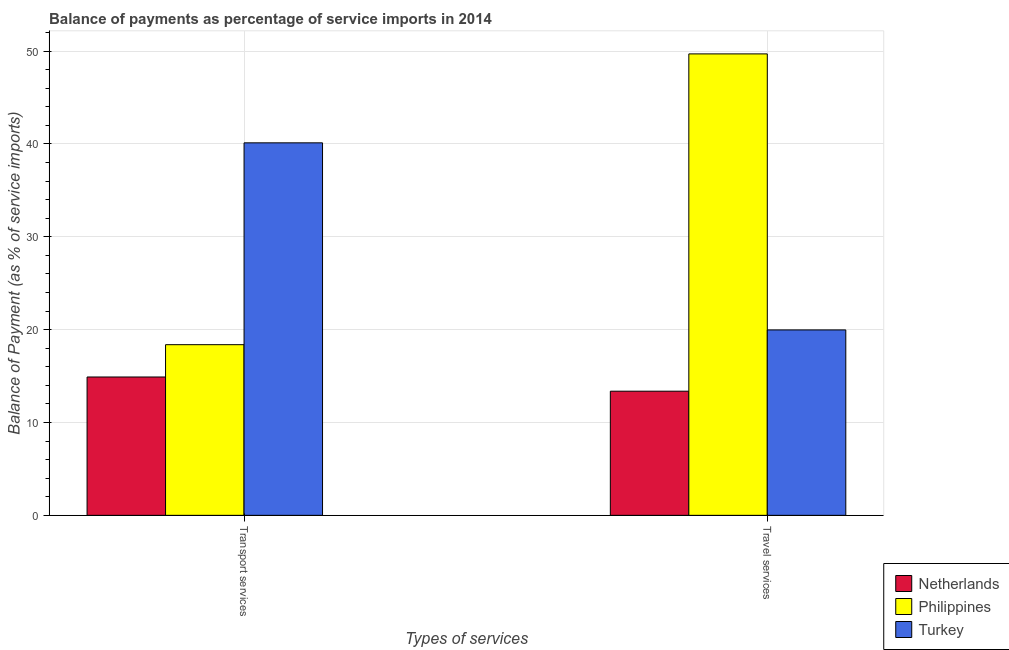How many different coloured bars are there?
Your answer should be very brief. 3. Are the number of bars per tick equal to the number of legend labels?
Offer a terse response. Yes. How many bars are there on the 2nd tick from the left?
Provide a short and direct response. 3. What is the label of the 1st group of bars from the left?
Keep it short and to the point. Transport services. What is the balance of payments of travel services in Turkey?
Your answer should be compact. 19.97. Across all countries, what is the maximum balance of payments of transport services?
Offer a very short reply. 40.12. Across all countries, what is the minimum balance of payments of travel services?
Ensure brevity in your answer.  13.37. In which country was the balance of payments of travel services maximum?
Your response must be concise. Philippines. In which country was the balance of payments of travel services minimum?
Give a very brief answer. Netherlands. What is the total balance of payments of travel services in the graph?
Your response must be concise. 83.03. What is the difference between the balance of payments of transport services in Turkey and that in Philippines?
Offer a terse response. 21.74. What is the difference between the balance of payments of transport services in Turkey and the balance of payments of travel services in Netherlands?
Keep it short and to the point. 26.75. What is the average balance of payments of travel services per country?
Make the answer very short. 27.68. What is the difference between the balance of payments of transport services and balance of payments of travel services in Turkey?
Offer a terse response. 20.15. What is the ratio of the balance of payments of transport services in Netherlands to that in Turkey?
Keep it short and to the point. 0.37. Is the balance of payments of transport services in Philippines less than that in Turkey?
Give a very brief answer. Yes. What does the 3rd bar from the left in Transport services represents?
Offer a very short reply. Turkey. How many bars are there?
Keep it short and to the point. 6. Are all the bars in the graph horizontal?
Offer a terse response. No. How many countries are there in the graph?
Your response must be concise. 3. Does the graph contain grids?
Offer a terse response. Yes. How are the legend labels stacked?
Offer a terse response. Vertical. What is the title of the graph?
Ensure brevity in your answer.  Balance of payments as percentage of service imports in 2014. Does "Sudan" appear as one of the legend labels in the graph?
Your answer should be compact. No. What is the label or title of the X-axis?
Keep it short and to the point. Types of services. What is the label or title of the Y-axis?
Provide a succinct answer. Balance of Payment (as % of service imports). What is the Balance of Payment (as % of service imports) in Netherlands in Transport services?
Your answer should be very brief. 14.9. What is the Balance of Payment (as % of service imports) of Philippines in Transport services?
Ensure brevity in your answer.  18.38. What is the Balance of Payment (as % of service imports) of Turkey in Transport services?
Offer a terse response. 40.12. What is the Balance of Payment (as % of service imports) in Netherlands in Travel services?
Provide a short and direct response. 13.37. What is the Balance of Payment (as % of service imports) of Philippines in Travel services?
Ensure brevity in your answer.  49.69. What is the Balance of Payment (as % of service imports) in Turkey in Travel services?
Your response must be concise. 19.97. Across all Types of services, what is the maximum Balance of Payment (as % of service imports) of Netherlands?
Offer a very short reply. 14.9. Across all Types of services, what is the maximum Balance of Payment (as % of service imports) in Philippines?
Your response must be concise. 49.69. Across all Types of services, what is the maximum Balance of Payment (as % of service imports) of Turkey?
Provide a succinct answer. 40.12. Across all Types of services, what is the minimum Balance of Payment (as % of service imports) in Netherlands?
Your response must be concise. 13.37. Across all Types of services, what is the minimum Balance of Payment (as % of service imports) of Philippines?
Ensure brevity in your answer.  18.38. Across all Types of services, what is the minimum Balance of Payment (as % of service imports) in Turkey?
Keep it short and to the point. 19.97. What is the total Balance of Payment (as % of service imports) in Netherlands in the graph?
Give a very brief answer. 28.27. What is the total Balance of Payment (as % of service imports) in Philippines in the graph?
Provide a succinct answer. 68.07. What is the total Balance of Payment (as % of service imports) in Turkey in the graph?
Ensure brevity in your answer.  60.09. What is the difference between the Balance of Payment (as % of service imports) of Netherlands in Transport services and that in Travel services?
Ensure brevity in your answer.  1.53. What is the difference between the Balance of Payment (as % of service imports) in Philippines in Transport services and that in Travel services?
Offer a terse response. -31.31. What is the difference between the Balance of Payment (as % of service imports) of Turkey in Transport services and that in Travel services?
Offer a terse response. 20.15. What is the difference between the Balance of Payment (as % of service imports) in Netherlands in Transport services and the Balance of Payment (as % of service imports) in Philippines in Travel services?
Your answer should be very brief. -34.79. What is the difference between the Balance of Payment (as % of service imports) of Netherlands in Transport services and the Balance of Payment (as % of service imports) of Turkey in Travel services?
Offer a terse response. -5.07. What is the difference between the Balance of Payment (as % of service imports) of Philippines in Transport services and the Balance of Payment (as % of service imports) of Turkey in Travel services?
Provide a succinct answer. -1.59. What is the average Balance of Payment (as % of service imports) of Netherlands per Types of services?
Provide a short and direct response. 14.13. What is the average Balance of Payment (as % of service imports) in Philippines per Types of services?
Ensure brevity in your answer.  34.04. What is the average Balance of Payment (as % of service imports) of Turkey per Types of services?
Your answer should be compact. 30.04. What is the difference between the Balance of Payment (as % of service imports) in Netherlands and Balance of Payment (as % of service imports) in Philippines in Transport services?
Offer a terse response. -3.48. What is the difference between the Balance of Payment (as % of service imports) of Netherlands and Balance of Payment (as % of service imports) of Turkey in Transport services?
Offer a very short reply. -25.22. What is the difference between the Balance of Payment (as % of service imports) in Philippines and Balance of Payment (as % of service imports) in Turkey in Transport services?
Offer a very short reply. -21.74. What is the difference between the Balance of Payment (as % of service imports) of Netherlands and Balance of Payment (as % of service imports) of Philippines in Travel services?
Ensure brevity in your answer.  -36.32. What is the difference between the Balance of Payment (as % of service imports) of Netherlands and Balance of Payment (as % of service imports) of Turkey in Travel services?
Offer a terse response. -6.6. What is the difference between the Balance of Payment (as % of service imports) in Philippines and Balance of Payment (as % of service imports) in Turkey in Travel services?
Keep it short and to the point. 29.72. What is the ratio of the Balance of Payment (as % of service imports) of Netherlands in Transport services to that in Travel services?
Make the answer very short. 1.11. What is the ratio of the Balance of Payment (as % of service imports) of Philippines in Transport services to that in Travel services?
Your answer should be compact. 0.37. What is the ratio of the Balance of Payment (as % of service imports) of Turkey in Transport services to that in Travel services?
Your answer should be compact. 2.01. What is the difference between the highest and the second highest Balance of Payment (as % of service imports) in Netherlands?
Your answer should be very brief. 1.53. What is the difference between the highest and the second highest Balance of Payment (as % of service imports) of Philippines?
Your answer should be very brief. 31.31. What is the difference between the highest and the second highest Balance of Payment (as % of service imports) in Turkey?
Keep it short and to the point. 20.15. What is the difference between the highest and the lowest Balance of Payment (as % of service imports) in Netherlands?
Your answer should be very brief. 1.53. What is the difference between the highest and the lowest Balance of Payment (as % of service imports) of Philippines?
Your answer should be very brief. 31.31. What is the difference between the highest and the lowest Balance of Payment (as % of service imports) in Turkey?
Provide a succinct answer. 20.15. 